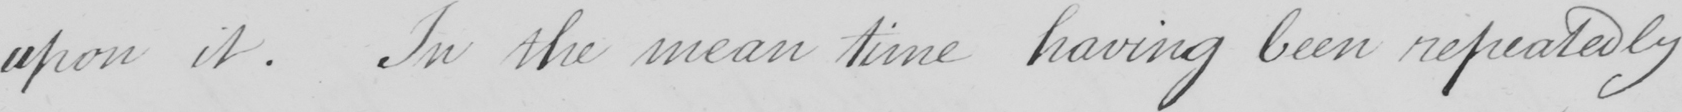What does this handwritten line say? upon it . In the mean time having been repeatedly 